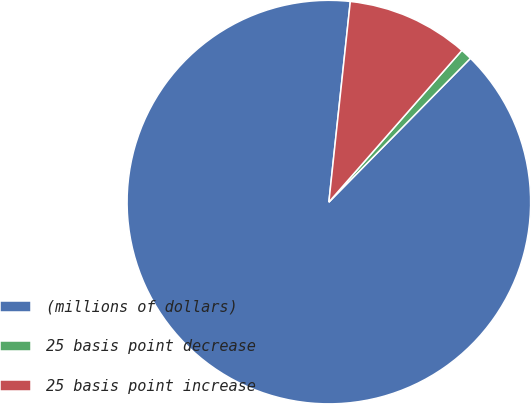<chart> <loc_0><loc_0><loc_500><loc_500><pie_chart><fcel>(millions of dollars)<fcel>25 basis point decrease<fcel>25 basis point increase<nl><fcel>89.32%<fcel>0.92%<fcel>9.76%<nl></chart> 